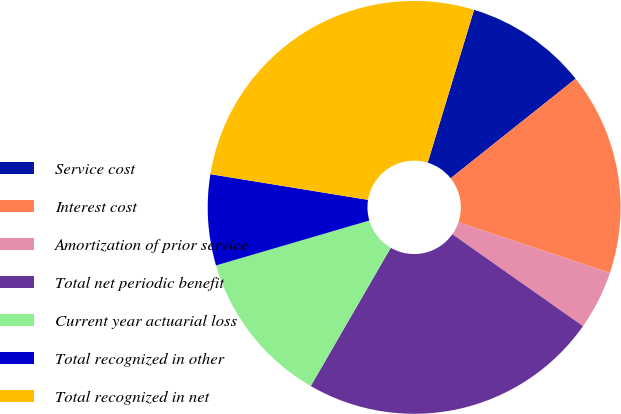<chart> <loc_0><loc_0><loc_500><loc_500><pie_chart><fcel>Service cost<fcel>Interest cost<fcel>Amortization of prior service<fcel>Total net periodic benefit<fcel>Current year actuarial loss<fcel>Total recognized in other<fcel>Total recognized in net<nl><fcel>9.61%<fcel>15.85%<fcel>4.61%<fcel>23.59%<fcel>12.11%<fcel>7.11%<fcel>27.11%<nl></chart> 